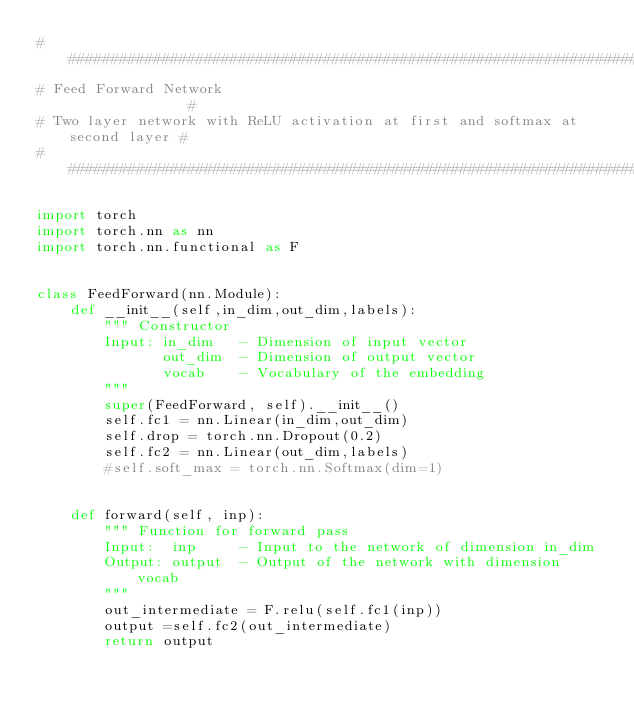<code> <loc_0><loc_0><loc_500><loc_500><_Python_>###############################################################################
# Feed Forward Network 			   											  #
# Two layer network with ReLU activation at first and softmax at second layer #
###############################################################################

import torch
import torch.nn as nn
import torch.nn.functional as F


class FeedForward(nn.Module):
	def __init__(self,in_dim,out_dim,labels):
		""" Constructor
		Input: in_dim	- Dimension of input vector
			   out_dim	- Dimension of output vector
			   vocab	- Vocabulary of the embedding
		"""
		super(FeedForward, self).__init__()
		self.fc1 = nn.Linear(in_dim,out_dim)
		self.drop = torch.nn.Dropout(0.2)
		self.fc2 = nn.Linear(out_dim,labels)
		#self.soft_max = torch.nn.Softmax(dim=1)


	def forward(self, inp):
		""" Function for forward pass
		Input:	inp 	- Input to the network of dimension in_dim
		Output: output 	- Output of the network with dimension vocab
		"""
		out_intermediate = F.relu(self.fc1(inp))
		output =self.fc2(out_intermediate)
		return output
</code> 